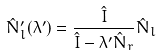<formula> <loc_0><loc_0><loc_500><loc_500>\hat { N } ^ { \prime } _ { l } ( \lambda ^ { \prime } ) = \frac { \hat { I } } { \hat { I } - \lambda ^ { \prime } \hat { N } _ { r } } \hat { N } _ { l }</formula> 